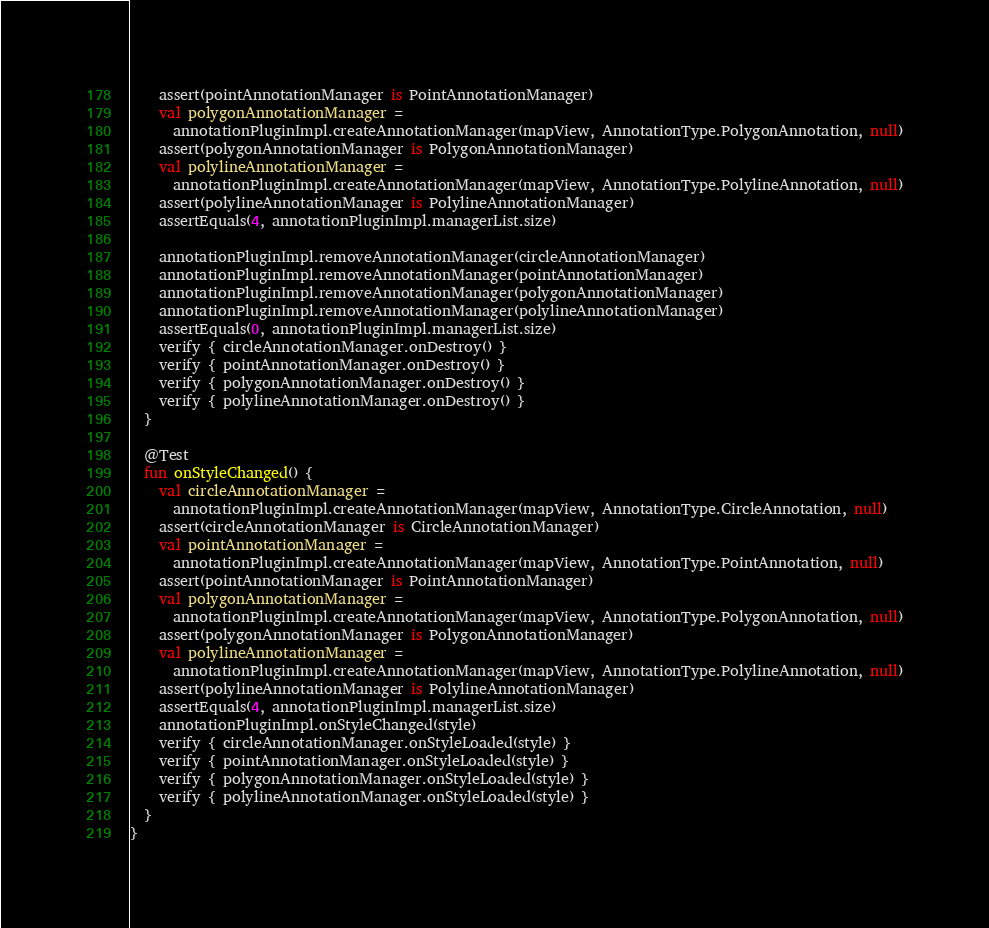Convert code to text. <code><loc_0><loc_0><loc_500><loc_500><_Kotlin_>    assert(pointAnnotationManager is PointAnnotationManager)
    val polygonAnnotationManager =
      annotationPluginImpl.createAnnotationManager(mapView, AnnotationType.PolygonAnnotation, null)
    assert(polygonAnnotationManager is PolygonAnnotationManager)
    val polylineAnnotationManager =
      annotationPluginImpl.createAnnotationManager(mapView, AnnotationType.PolylineAnnotation, null)
    assert(polylineAnnotationManager is PolylineAnnotationManager)
    assertEquals(4, annotationPluginImpl.managerList.size)

    annotationPluginImpl.removeAnnotationManager(circleAnnotationManager)
    annotationPluginImpl.removeAnnotationManager(pointAnnotationManager)
    annotationPluginImpl.removeAnnotationManager(polygonAnnotationManager)
    annotationPluginImpl.removeAnnotationManager(polylineAnnotationManager)
    assertEquals(0, annotationPluginImpl.managerList.size)
    verify { circleAnnotationManager.onDestroy() }
    verify { pointAnnotationManager.onDestroy() }
    verify { polygonAnnotationManager.onDestroy() }
    verify { polylineAnnotationManager.onDestroy() }
  }

  @Test
  fun onStyleChanged() {
    val circleAnnotationManager =
      annotationPluginImpl.createAnnotationManager(mapView, AnnotationType.CircleAnnotation, null)
    assert(circleAnnotationManager is CircleAnnotationManager)
    val pointAnnotationManager =
      annotationPluginImpl.createAnnotationManager(mapView, AnnotationType.PointAnnotation, null)
    assert(pointAnnotationManager is PointAnnotationManager)
    val polygonAnnotationManager =
      annotationPluginImpl.createAnnotationManager(mapView, AnnotationType.PolygonAnnotation, null)
    assert(polygonAnnotationManager is PolygonAnnotationManager)
    val polylineAnnotationManager =
      annotationPluginImpl.createAnnotationManager(mapView, AnnotationType.PolylineAnnotation, null)
    assert(polylineAnnotationManager is PolylineAnnotationManager)
    assertEquals(4, annotationPluginImpl.managerList.size)
    annotationPluginImpl.onStyleChanged(style)
    verify { circleAnnotationManager.onStyleLoaded(style) }
    verify { pointAnnotationManager.onStyleLoaded(style) }
    verify { polygonAnnotationManager.onStyleLoaded(style) }
    verify { polylineAnnotationManager.onStyleLoaded(style) }
  }
}</code> 